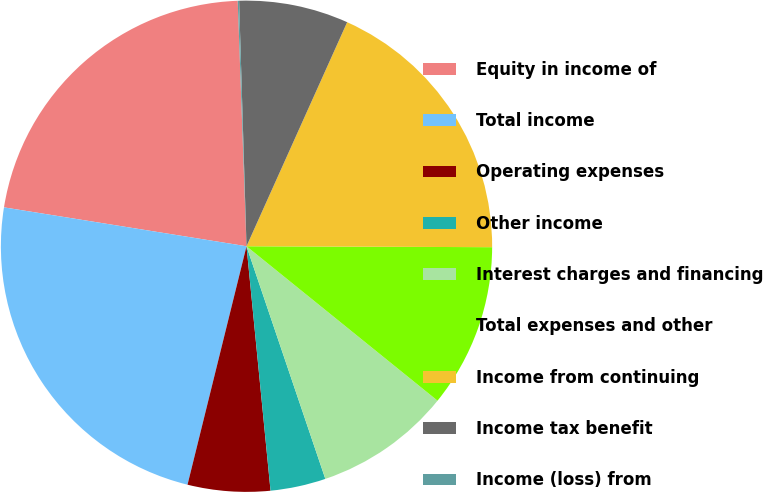Convert chart to OTSL. <chart><loc_0><loc_0><loc_500><loc_500><pie_chart><fcel>Equity in income of<fcel>Total income<fcel>Operating expenses<fcel>Other income<fcel>Interest charges and financing<fcel>Total expenses and other<fcel>Income from continuing<fcel>Income tax benefit<fcel>Income (loss) from<nl><fcel>21.9%<fcel>23.67%<fcel>5.42%<fcel>3.64%<fcel>8.98%<fcel>10.76%<fcel>18.34%<fcel>7.2%<fcel>0.09%<nl></chart> 